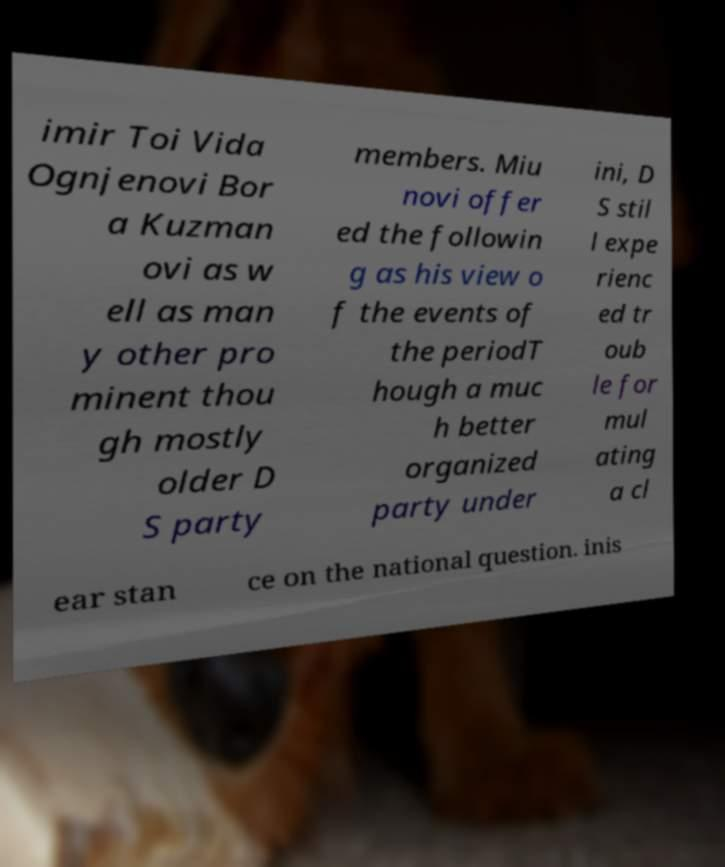I need the written content from this picture converted into text. Can you do that? imir Toi Vida Ognjenovi Bor a Kuzman ovi as w ell as man y other pro minent thou gh mostly older D S party members. Miu novi offer ed the followin g as his view o f the events of the periodT hough a muc h better organized party under ini, D S stil l expe rienc ed tr oub le for mul ating a cl ear stan ce on the national question. inis 